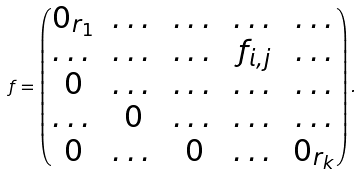<formula> <loc_0><loc_0><loc_500><loc_500>f = \begin{pmatrix} 0 _ { r _ { 1 } } & \dots & \dots & \dots & \dots \\ \dots & \dots & \dots & f _ { i , j } & \dots \\ 0 & \dots & \dots & \dots & \dots \\ \dots & 0 & \dots & \dots & \dots \\ 0 & \dots & 0 & \dots & 0 _ { r _ { k } } \end{pmatrix} .</formula> 